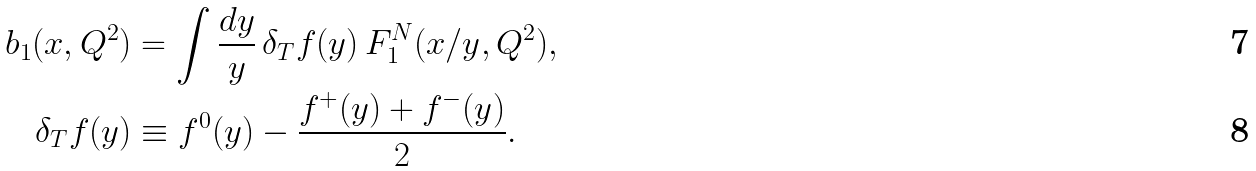Convert formula to latex. <formula><loc_0><loc_0><loc_500><loc_500>b _ { 1 } ( x , Q ^ { 2 } ) & = \int \frac { d y } { y } \, \delta _ { T } f ( y ) \, F _ { 1 } ^ { N } ( x / y , Q ^ { 2 } ) , \\ \delta _ { T } f ( y ) & \equiv f ^ { 0 } ( y ) - \frac { f ^ { + } ( y ) + f ^ { - } ( y ) } { 2 } .</formula> 